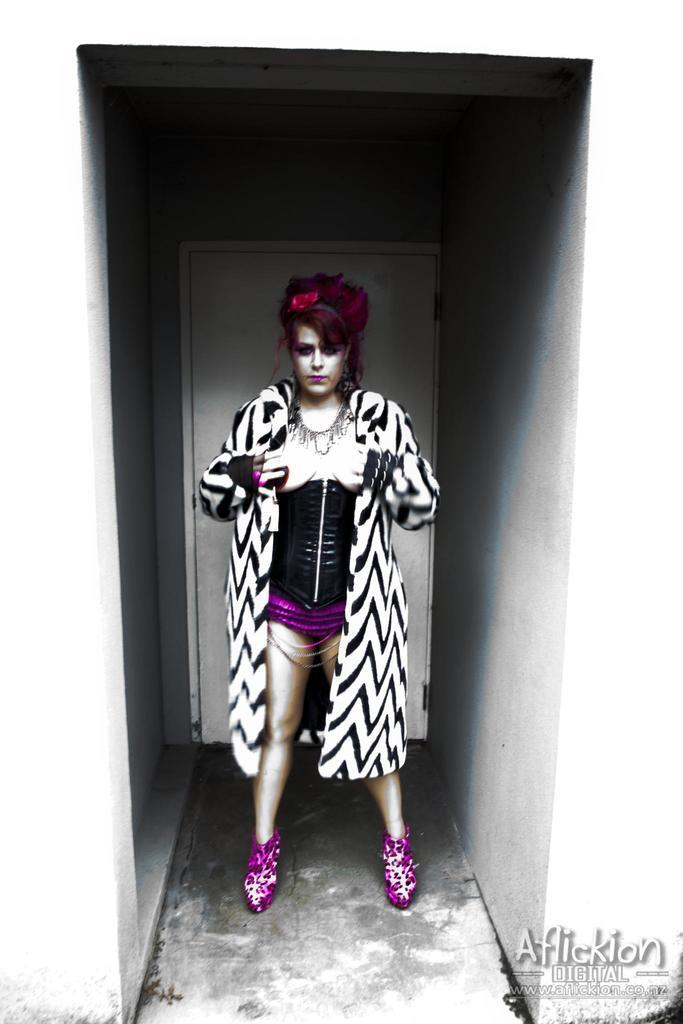Who is present in the image? There is a woman in the image. What is the woman wearing? The woman is wearing a jacket. What surface is the woman standing on? The woman is standing on the floor. What can be seen in the background of the image? There is a door in the background of the image. How is the door connected to the surrounding structure? The door is connected to a wall. How many frogs are sitting on the woman's head in the image? There are no frogs present in the image, so it is not possible to answer that question. 